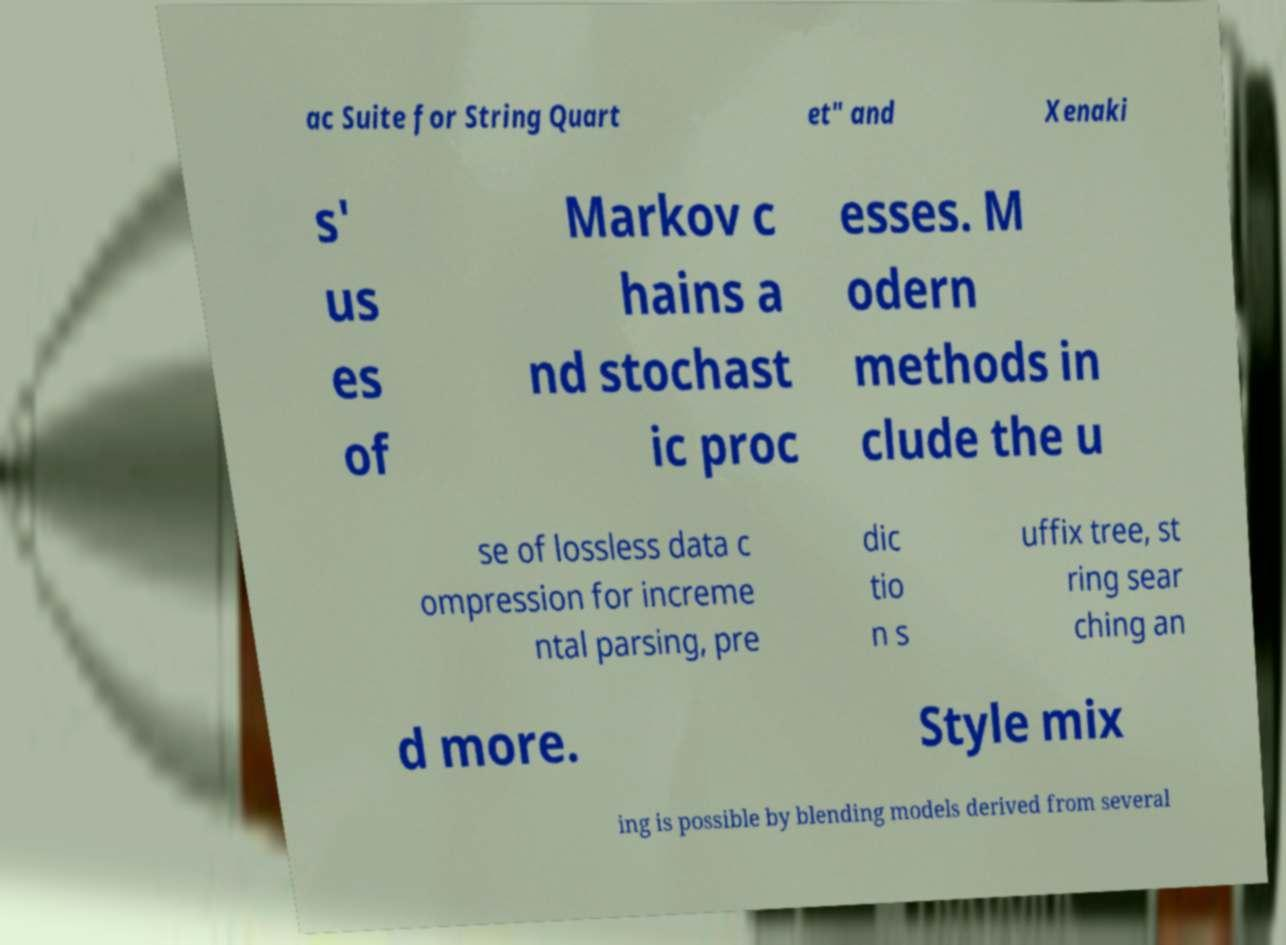There's text embedded in this image that I need extracted. Can you transcribe it verbatim? ac Suite for String Quart et" and Xenaki s' us es of Markov c hains a nd stochast ic proc esses. M odern methods in clude the u se of lossless data c ompression for increme ntal parsing, pre dic tio n s uffix tree, st ring sear ching an d more. Style mix ing is possible by blending models derived from several 